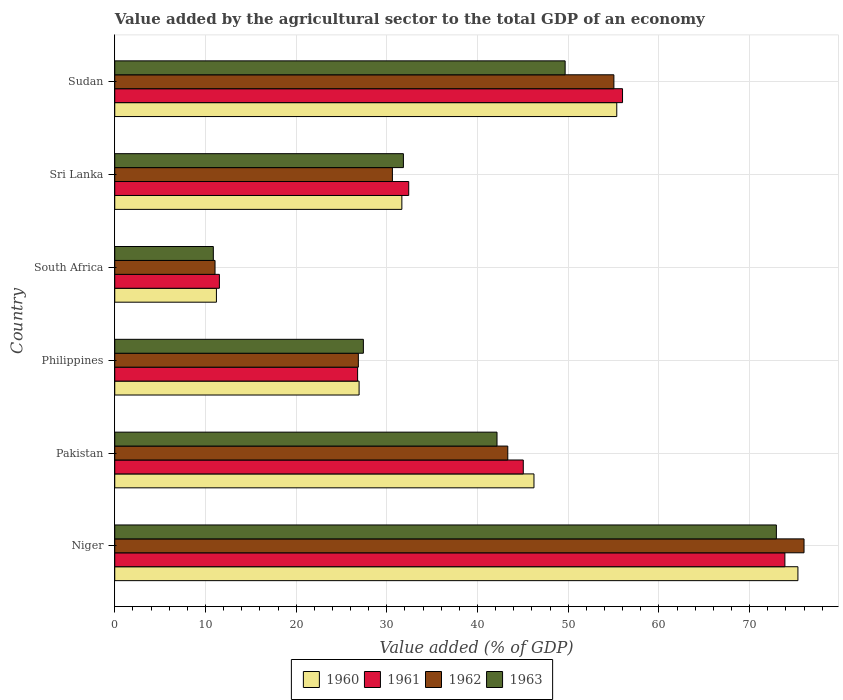How many groups of bars are there?
Your answer should be very brief. 6. Are the number of bars per tick equal to the number of legend labels?
Your response must be concise. Yes. How many bars are there on the 3rd tick from the top?
Provide a succinct answer. 4. What is the value added by the agricultural sector to the total GDP in 1962 in Philippines?
Provide a short and direct response. 26.86. Across all countries, what is the maximum value added by the agricultural sector to the total GDP in 1960?
Ensure brevity in your answer.  75.32. Across all countries, what is the minimum value added by the agricultural sector to the total GDP in 1963?
Keep it short and to the point. 10.87. In which country was the value added by the agricultural sector to the total GDP in 1963 maximum?
Give a very brief answer. Niger. In which country was the value added by the agricultural sector to the total GDP in 1960 minimum?
Provide a succinct answer. South Africa. What is the total value added by the agricultural sector to the total GDP in 1961 in the graph?
Your answer should be very brief. 245.64. What is the difference between the value added by the agricultural sector to the total GDP in 1961 in Philippines and that in Sudan?
Your answer should be very brief. -29.21. What is the difference between the value added by the agricultural sector to the total GDP in 1960 in Sudan and the value added by the agricultural sector to the total GDP in 1962 in Sri Lanka?
Offer a very short reply. 24.74. What is the average value added by the agricultural sector to the total GDP in 1961 per country?
Provide a succinct answer. 40.94. What is the difference between the value added by the agricultural sector to the total GDP in 1961 and value added by the agricultural sector to the total GDP in 1963 in Niger?
Keep it short and to the point. 0.94. In how many countries, is the value added by the agricultural sector to the total GDP in 1962 greater than 26 %?
Give a very brief answer. 5. What is the ratio of the value added by the agricultural sector to the total GDP in 1961 in Philippines to that in Sri Lanka?
Your response must be concise. 0.83. Is the value added by the agricultural sector to the total GDP in 1961 in Pakistan less than that in Sri Lanka?
Offer a very short reply. No. What is the difference between the highest and the second highest value added by the agricultural sector to the total GDP in 1961?
Make the answer very short. 17.9. What is the difference between the highest and the lowest value added by the agricultural sector to the total GDP in 1960?
Keep it short and to the point. 64.11. Is the sum of the value added by the agricultural sector to the total GDP in 1960 in South Africa and Sri Lanka greater than the maximum value added by the agricultural sector to the total GDP in 1963 across all countries?
Give a very brief answer. No. Is it the case that in every country, the sum of the value added by the agricultural sector to the total GDP in 1962 and value added by the agricultural sector to the total GDP in 1961 is greater than the sum of value added by the agricultural sector to the total GDP in 1960 and value added by the agricultural sector to the total GDP in 1963?
Give a very brief answer. No. What does the 3rd bar from the bottom in Niger represents?
Provide a short and direct response. 1962. How many bars are there?
Provide a short and direct response. 24. Are all the bars in the graph horizontal?
Offer a very short reply. Yes. How many countries are there in the graph?
Give a very brief answer. 6. Are the values on the major ticks of X-axis written in scientific E-notation?
Provide a short and direct response. No. Does the graph contain grids?
Your answer should be compact. Yes. How many legend labels are there?
Provide a succinct answer. 4. What is the title of the graph?
Your response must be concise. Value added by the agricultural sector to the total GDP of an economy. Does "1978" appear as one of the legend labels in the graph?
Offer a terse response. No. What is the label or title of the X-axis?
Make the answer very short. Value added (% of GDP). What is the Value added (% of GDP) in 1960 in Niger?
Provide a succinct answer. 75.32. What is the Value added (% of GDP) in 1961 in Niger?
Your answer should be very brief. 73.89. What is the Value added (% of GDP) in 1962 in Niger?
Give a very brief answer. 76. What is the Value added (% of GDP) of 1963 in Niger?
Provide a short and direct response. 72.95. What is the Value added (% of GDP) of 1960 in Pakistan?
Ensure brevity in your answer.  46.22. What is the Value added (% of GDP) of 1961 in Pakistan?
Give a very brief answer. 45.04. What is the Value added (% of GDP) of 1962 in Pakistan?
Offer a terse response. 43.33. What is the Value added (% of GDP) of 1963 in Pakistan?
Offer a terse response. 42.15. What is the Value added (% of GDP) of 1960 in Philippines?
Keep it short and to the point. 26.94. What is the Value added (% of GDP) of 1961 in Philippines?
Your answer should be very brief. 26.78. What is the Value added (% of GDP) of 1962 in Philippines?
Your answer should be compact. 26.86. What is the Value added (% of GDP) of 1963 in Philippines?
Provide a short and direct response. 27.41. What is the Value added (% of GDP) of 1960 in South Africa?
Provide a short and direct response. 11.21. What is the Value added (% of GDP) in 1961 in South Africa?
Provide a short and direct response. 11.54. What is the Value added (% of GDP) of 1962 in South Africa?
Your response must be concise. 11.06. What is the Value added (% of GDP) in 1963 in South Africa?
Your answer should be compact. 10.87. What is the Value added (% of GDP) in 1960 in Sri Lanka?
Give a very brief answer. 31.66. What is the Value added (% of GDP) in 1961 in Sri Lanka?
Offer a very short reply. 32.41. What is the Value added (% of GDP) of 1962 in Sri Lanka?
Give a very brief answer. 30.61. What is the Value added (% of GDP) of 1963 in Sri Lanka?
Provide a succinct answer. 31.83. What is the Value added (% of GDP) of 1960 in Sudan?
Your answer should be very brief. 55.35. What is the Value added (% of GDP) of 1961 in Sudan?
Make the answer very short. 55.99. What is the Value added (% of GDP) in 1962 in Sudan?
Your response must be concise. 55.03. What is the Value added (% of GDP) of 1963 in Sudan?
Keep it short and to the point. 49.66. Across all countries, what is the maximum Value added (% of GDP) of 1960?
Your response must be concise. 75.32. Across all countries, what is the maximum Value added (% of GDP) of 1961?
Your response must be concise. 73.89. Across all countries, what is the maximum Value added (% of GDP) of 1962?
Give a very brief answer. 76. Across all countries, what is the maximum Value added (% of GDP) of 1963?
Make the answer very short. 72.95. Across all countries, what is the minimum Value added (% of GDP) of 1960?
Your answer should be compact. 11.21. Across all countries, what is the minimum Value added (% of GDP) in 1961?
Offer a very short reply. 11.54. Across all countries, what is the minimum Value added (% of GDP) in 1962?
Your response must be concise. 11.06. Across all countries, what is the minimum Value added (% of GDP) in 1963?
Your answer should be compact. 10.87. What is the total Value added (% of GDP) in 1960 in the graph?
Provide a short and direct response. 246.7. What is the total Value added (% of GDP) in 1961 in the graph?
Offer a very short reply. 245.64. What is the total Value added (% of GDP) in 1962 in the graph?
Your response must be concise. 242.89. What is the total Value added (% of GDP) of 1963 in the graph?
Offer a very short reply. 234.86. What is the difference between the Value added (% of GDP) of 1960 in Niger and that in Pakistan?
Provide a succinct answer. 29.1. What is the difference between the Value added (% of GDP) of 1961 in Niger and that in Pakistan?
Make the answer very short. 28.84. What is the difference between the Value added (% of GDP) in 1962 in Niger and that in Pakistan?
Your answer should be compact. 32.66. What is the difference between the Value added (% of GDP) in 1963 in Niger and that in Pakistan?
Provide a short and direct response. 30.8. What is the difference between the Value added (% of GDP) of 1960 in Niger and that in Philippines?
Make the answer very short. 48.38. What is the difference between the Value added (% of GDP) in 1961 in Niger and that in Philippines?
Offer a very short reply. 47.11. What is the difference between the Value added (% of GDP) of 1962 in Niger and that in Philippines?
Your answer should be compact. 49.14. What is the difference between the Value added (% of GDP) of 1963 in Niger and that in Philippines?
Keep it short and to the point. 45.54. What is the difference between the Value added (% of GDP) of 1960 in Niger and that in South Africa?
Offer a very short reply. 64.11. What is the difference between the Value added (% of GDP) in 1961 in Niger and that in South Africa?
Offer a very short reply. 62.35. What is the difference between the Value added (% of GDP) in 1962 in Niger and that in South Africa?
Your answer should be compact. 64.94. What is the difference between the Value added (% of GDP) of 1963 in Niger and that in South Africa?
Make the answer very short. 62.08. What is the difference between the Value added (% of GDP) of 1960 in Niger and that in Sri Lanka?
Your response must be concise. 43.67. What is the difference between the Value added (% of GDP) in 1961 in Niger and that in Sri Lanka?
Offer a very short reply. 41.48. What is the difference between the Value added (% of GDP) of 1962 in Niger and that in Sri Lanka?
Ensure brevity in your answer.  45.38. What is the difference between the Value added (% of GDP) in 1963 in Niger and that in Sri Lanka?
Your answer should be very brief. 41.12. What is the difference between the Value added (% of GDP) in 1960 in Niger and that in Sudan?
Offer a terse response. 19.97. What is the difference between the Value added (% of GDP) in 1961 in Niger and that in Sudan?
Your response must be concise. 17.9. What is the difference between the Value added (% of GDP) in 1962 in Niger and that in Sudan?
Provide a short and direct response. 20.96. What is the difference between the Value added (% of GDP) in 1963 in Niger and that in Sudan?
Offer a very short reply. 23.29. What is the difference between the Value added (% of GDP) of 1960 in Pakistan and that in Philippines?
Your answer should be compact. 19.28. What is the difference between the Value added (% of GDP) of 1961 in Pakistan and that in Philippines?
Your answer should be compact. 18.27. What is the difference between the Value added (% of GDP) of 1962 in Pakistan and that in Philippines?
Your response must be concise. 16.48. What is the difference between the Value added (% of GDP) in 1963 in Pakistan and that in Philippines?
Offer a terse response. 14.73. What is the difference between the Value added (% of GDP) in 1960 in Pakistan and that in South Africa?
Ensure brevity in your answer.  35.01. What is the difference between the Value added (% of GDP) in 1961 in Pakistan and that in South Africa?
Offer a terse response. 33.51. What is the difference between the Value added (% of GDP) of 1962 in Pakistan and that in South Africa?
Ensure brevity in your answer.  32.28. What is the difference between the Value added (% of GDP) of 1963 in Pakistan and that in South Africa?
Offer a terse response. 31.28. What is the difference between the Value added (% of GDP) in 1960 in Pakistan and that in Sri Lanka?
Your response must be concise. 14.56. What is the difference between the Value added (% of GDP) in 1961 in Pakistan and that in Sri Lanka?
Provide a short and direct response. 12.63. What is the difference between the Value added (% of GDP) in 1962 in Pakistan and that in Sri Lanka?
Give a very brief answer. 12.72. What is the difference between the Value added (% of GDP) of 1963 in Pakistan and that in Sri Lanka?
Provide a short and direct response. 10.32. What is the difference between the Value added (% of GDP) of 1960 in Pakistan and that in Sudan?
Your answer should be compact. -9.13. What is the difference between the Value added (% of GDP) in 1961 in Pakistan and that in Sudan?
Provide a short and direct response. -10.94. What is the difference between the Value added (% of GDP) of 1962 in Pakistan and that in Sudan?
Provide a succinct answer. -11.7. What is the difference between the Value added (% of GDP) in 1963 in Pakistan and that in Sudan?
Offer a very short reply. -7.51. What is the difference between the Value added (% of GDP) in 1960 in Philippines and that in South Africa?
Ensure brevity in your answer.  15.73. What is the difference between the Value added (% of GDP) in 1961 in Philippines and that in South Africa?
Keep it short and to the point. 15.24. What is the difference between the Value added (% of GDP) in 1962 in Philippines and that in South Africa?
Offer a very short reply. 15.8. What is the difference between the Value added (% of GDP) of 1963 in Philippines and that in South Africa?
Provide a succinct answer. 16.54. What is the difference between the Value added (% of GDP) of 1960 in Philippines and that in Sri Lanka?
Provide a succinct answer. -4.72. What is the difference between the Value added (% of GDP) of 1961 in Philippines and that in Sri Lanka?
Make the answer very short. -5.63. What is the difference between the Value added (% of GDP) in 1962 in Philippines and that in Sri Lanka?
Make the answer very short. -3.76. What is the difference between the Value added (% of GDP) of 1963 in Philippines and that in Sri Lanka?
Provide a short and direct response. -4.41. What is the difference between the Value added (% of GDP) of 1960 in Philippines and that in Sudan?
Your answer should be compact. -28.41. What is the difference between the Value added (% of GDP) in 1961 in Philippines and that in Sudan?
Keep it short and to the point. -29.21. What is the difference between the Value added (% of GDP) in 1962 in Philippines and that in Sudan?
Offer a terse response. -28.18. What is the difference between the Value added (% of GDP) in 1963 in Philippines and that in Sudan?
Your response must be concise. -22.25. What is the difference between the Value added (% of GDP) of 1960 in South Africa and that in Sri Lanka?
Give a very brief answer. -20.45. What is the difference between the Value added (% of GDP) of 1961 in South Africa and that in Sri Lanka?
Offer a terse response. -20.87. What is the difference between the Value added (% of GDP) of 1962 in South Africa and that in Sri Lanka?
Your answer should be very brief. -19.56. What is the difference between the Value added (% of GDP) of 1963 in South Africa and that in Sri Lanka?
Offer a very short reply. -20.96. What is the difference between the Value added (% of GDP) in 1960 in South Africa and that in Sudan?
Ensure brevity in your answer.  -44.14. What is the difference between the Value added (% of GDP) in 1961 in South Africa and that in Sudan?
Provide a succinct answer. -44.45. What is the difference between the Value added (% of GDP) of 1962 in South Africa and that in Sudan?
Provide a short and direct response. -43.98. What is the difference between the Value added (% of GDP) of 1963 in South Africa and that in Sudan?
Provide a succinct answer. -38.79. What is the difference between the Value added (% of GDP) of 1960 in Sri Lanka and that in Sudan?
Give a very brief answer. -23.7. What is the difference between the Value added (% of GDP) in 1961 in Sri Lanka and that in Sudan?
Offer a very short reply. -23.58. What is the difference between the Value added (% of GDP) in 1962 in Sri Lanka and that in Sudan?
Offer a terse response. -24.42. What is the difference between the Value added (% of GDP) of 1963 in Sri Lanka and that in Sudan?
Your answer should be compact. -17.83. What is the difference between the Value added (% of GDP) of 1960 in Niger and the Value added (% of GDP) of 1961 in Pakistan?
Offer a very short reply. 30.28. What is the difference between the Value added (% of GDP) of 1960 in Niger and the Value added (% of GDP) of 1962 in Pakistan?
Ensure brevity in your answer.  31.99. What is the difference between the Value added (% of GDP) of 1960 in Niger and the Value added (% of GDP) of 1963 in Pakistan?
Provide a short and direct response. 33.18. What is the difference between the Value added (% of GDP) of 1961 in Niger and the Value added (% of GDP) of 1962 in Pakistan?
Give a very brief answer. 30.55. What is the difference between the Value added (% of GDP) of 1961 in Niger and the Value added (% of GDP) of 1963 in Pakistan?
Offer a very short reply. 31.74. What is the difference between the Value added (% of GDP) of 1962 in Niger and the Value added (% of GDP) of 1963 in Pakistan?
Offer a terse response. 33.85. What is the difference between the Value added (% of GDP) in 1960 in Niger and the Value added (% of GDP) in 1961 in Philippines?
Give a very brief answer. 48.55. What is the difference between the Value added (% of GDP) of 1960 in Niger and the Value added (% of GDP) of 1962 in Philippines?
Offer a terse response. 48.47. What is the difference between the Value added (% of GDP) of 1960 in Niger and the Value added (% of GDP) of 1963 in Philippines?
Keep it short and to the point. 47.91. What is the difference between the Value added (% of GDP) in 1961 in Niger and the Value added (% of GDP) in 1962 in Philippines?
Keep it short and to the point. 47.03. What is the difference between the Value added (% of GDP) in 1961 in Niger and the Value added (% of GDP) in 1963 in Philippines?
Your answer should be very brief. 46.48. What is the difference between the Value added (% of GDP) in 1962 in Niger and the Value added (% of GDP) in 1963 in Philippines?
Ensure brevity in your answer.  48.59. What is the difference between the Value added (% of GDP) in 1960 in Niger and the Value added (% of GDP) in 1961 in South Africa?
Ensure brevity in your answer.  63.79. What is the difference between the Value added (% of GDP) of 1960 in Niger and the Value added (% of GDP) of 1962 in South Africa?
Offer a very short reply. 64.27. What is the difference between the Value added (% of GDP) of 1960 in Niger and the Value added (% of GDP) of 1963 in South Africa?
Keep it short and to the point. 64.46. What is the difference between the Value added (% of GDP) in 1961 in Niger and the Value added (% of GDP) in 1962 in South Africa?
Keep it short and to the point. 62.83. What is the difference between the Value added (% of GDP) of 1961 in Niger and the Value added (% of GDP) of 1963 in South Africa?
Make the answer very short. 63.02. What is the difference between the Value added (% of GDP) in 1962 in Niger and the Value added (% of GDP) in 1963 in South Africa?
Provide a succinct answer. 65.13. What is the difference between the Value added (% of GDP) of 1960 in Niger and the Value added (% of GDP) of 1961 in Sri Lanka?
Keep it short and to the point. 42.91. What is the difference between the Value added (% of GDP) in 1960 in Niger and the Value added (% of GDP) in 1962 in Sri Lanka?
Provide a succinct answer. 44.71. What is the difference between the Value added (% of GDP) in 1960 in Niger and the Value added (% of GDP) in 1963 in Sri Lanka?
Offer a very short reply. 43.5. What is the difference between the Value added (% of GDP) of 1961 in Niger and the Value added (% of GDP) of 1962 in Sri Lanka?
Provide a succinct answer. 43.27. What is the difference between the Value added (% of GDP) in 1961 in Niger and the Value added (% of GDP) in 1963 in Sri Lanka?
Provide a short and direct response. 42.06. What is the difference between the Value added (% of GDP) of 1962 in Niger and the Value added (% of GDP) of 1963 in Sri Lanka?
Your answer should be compact. 44.17. What is the difference between the Value added (% of GDP) of 1960 in Niger and the Value added (% of GDP) of 1961 in Sudan?
Offer a terse response. 19.34. What is the difference between the Value added (% of GDP) in 1960 in Niger and the Value added (% of GDP) in 1962 in Sudan?
Give a very brief answer. 20.29. What is the difference between the Value added (% of GDP) of 1960 in Niger and the Value added (% of GDP) of 1963 in Sudan?
Offer a very short reply. 25.67. What is the difference between the Value added (% of GDP) in 1961 in Niger and the Value added (% of GDP) in 1962 in Sudan?
Offer a very short reply. 18.85. What is the difference between the Value added (% of GDP) in 1961 in Niger and the Value added (% of GDP) in 1963 in Sudan?
Make the answer very short. 24.23. What is the difference between the Value added (% of GDP) in 1962 in Niger and the Value added (% of GDP) in 1963 in Sudan?
Provide a succinct answer. 26.34. What is the difference between the Value added (% of GDP) in 1960 in Pakistan and the Value added (% of GDP) in 1961 in Philippines?
Provide a succinct answer. 19.44. What is the difference between the Value added (% of GDP) in 1960 in Pakistan and the Value added (% of GDP) in 1962 in Philippines?
Your response must be concise. 19.36. What is the difference between the Value added (% of GDP) in 1960 in Pakistan and the Value added (% of GDP) in 1963 in Philippines?
Provide a succinct answer. 18.81. What is the difference between the Value added (% of GDP) in 1961 in Pakistan and the Value added (% of GDP) in 1962 in Philippines?
Offer a terse response. 18.19. What is the difference between the Value added (% of GDP) in 1961 in Pakistan and the Value added (% of GDP) in 1963 in Philippines?
Make the answer very short. 17.63. What is the difference between the Value added (% of GDP) of 1962 in Pakistan and the Value added (% of GDP) of 1963 in Philippines?
Offer a terse response. 15.92. What is the difference between the Value added (% of GDP) in 1960 in Pakistan and the Value added (% of GDP) in 1961 in South Africa?
Offer a very short reply. 34.68. What is the difference between the Value added (% of GDP) of 1960 in Pakistan and the Value added (% of GDP) of 1962 in South Africa?
Provide a short and direct response. 35.16. What is the difference between the Value added (% of GDP) of 1960 in Pakistan and the Value added (% of GDP) of 1963 in South Africa?
Provide a short and direct response. 35.35. What is the difference between the Value added (% of GDP) in 1961 in Pakistan and the Value added (% of GDP) in 1962 in South Africa?
Your answer should be very brief. 33.99. What is the difference between the Value added (% of GDP) of 1961 in Pakistan and the Value added (% of GDP) of 1963 in South Africa?
Your response must be concise. 34.17. What is the difference between the Value added (% of GDP) of 1962 in Pakistan and the Value added (% of GDP) of 1963 in South Africa?
Provide a succinct answer. 32.46. What is the difference between the Value added (% of GDP) in 1960 in Pakistan and the Value added (% of GDP) in 1961 in Sri Lanka?
Your answer should be very brief. 13.81. What is the difference between the Value added (% of GDP) in 1960 in Pakistan and the Value added (% of GDP) in 1962 in Sri Lanka?
Provide a succinct answer. 15.61. What is the difference between the Value added (% of GDP) in 1960 in Pakistan and the Value added (% of GDP) in 1963 in Sri Lanka?
Make the answer very short. 14.39. What is the difference between the Value added (% of GDP) in 1961 in Pakistan and the Value added (% of GDP) in 1962 in Sri Lanka?
Keep it short and to the point. 14.43. What is the difference between the Value added (% of GDP) of 1961 in Pakistan and the Value added (% of GDP) of 1963 in Sri Lanka?
Make the answer very short. 13.22. What is the difference between the Value added (% of GDP) in 1962 in Pakistan and the Value added (% of GDP) in 1963 in Sri Lanka?
Provide a succinct answer. 11.51. What is the difference between the Value added (% of GDP) of 1960 in Pakistan and the Value added (% of GDP) of 1961 in Sudan?
Make the answer very short. -9.77. What is the difference between the Value added (% of GDP) of 1960 in Pakistan and the Value added (% of GDP) of 1962 in Sudan?
Make the answer very short. -8.81. What is the difference between the Value added (% of GDP) in 1960 in Pakistan and the Value added (% of GDP) in 1963 in Sudan?
Your answer should be compact. -3.44. What is the difference between the Value added (% of GDP) in 1961 in Pakistan and the Value added (% of GDP) in 1962 in Sudan?
Make the answer very short. -9.99. What is the difference between the Value added (% of GDP) in 1961 in Pakistan and the Value added (% of GDP) in 1963 in Sudan?
Give a very brief answer. -4.62. What is the difference between the Value added (% of GDP) of 1962 in Pakistan and the Value added (% of GDP) of 1963 in Sudan?
Make the answer very short. -6.33. What is the difference between the Value added (% of GDP) in 1960 in Philippines and the Value added (% of GDP) in 1961 in South Africa?
Your response must be concise. 15.4. What is the difference between the Value added (% of GDP) of 1960 in Philippines and the Value added (% of GDP) of 1962 in South Africa?
Your answer should be very brief. 15.88. What is the difference between the Value added (% of GDP) in 1960 in Philippines and the Value added (% of GDP) in 1963 in South Africa?
Provide a succinct answer. 16.07. What is the difference between the Value added (% of GDP) of 1961 in Philippines and the Value added (% of GDP) of 1962 in South Africa?
Ensure brevity in your answer.  15.72. What is the difference between the Value added (% of GDP) of 1961 in Philippines and the Value added (% of GDP) of 1963 in South Africa?
Offer a terse response. 15.91. What is the difference between the Value added (% of GDP) of 1962 in Philippines and the Value added (% of GDP) of 1963 in South Africa?
Offer a very short reply. 15.99. What is the difference between the Value added (% of GDP) in 1960 in Philippines and the Value added (% of GDP) in 1961 in Sri Lanka?
Your answer should be very brief. -5.47. What is the difference between the Value added (% of GDP) in 1960 in Philippines and the Value added (% of GDP) in 1962 in Sri Lanka?
Keep it short and to the point. -3.67. What is the difference between the Value added (% of GDP) in 1960 in Philippines and the Value added (% of GDP) in 1963 in Sri Lanka?
Ensure brevity in your answer.  -4.89. What is the difference between the Value added (% of GDP) of 1961 in Philippines and the Value added (% of GDP) of 1962 in Sri Lanka?
Ensure brevity in your answer.  -3.84. What is the difference between the Value added (% of GDP) of 1961 in Philippines and the Value added (% of GDP) of 1963 in Sri Lanka?
Provide a short and direct response. -5.05. What is the difference between the Value added (% of GDP) of 1962 in Philippines and the Value added (% of GDP) of 1963 in Sri Lanka?
Your answer should be very brief. -4.97. What is the difference between the Value added (% of GDP) in 1960 in Philippines and the Value added (% of GDP) in 1961 in Sudan?
Ensure brevity in your answer.  -29.05. What is the difference between the Value added (% of GDP) in 1960 in Philippines and the Value added (% of GDP) in 1962 in Sudan?
Your answer should be very brief. -28.09. What is the difference between the Value added (% of GDP) in 1960 in Philippines and the Value added (% of GDP) in 1963 in Sudan?
Your answer should be compact. -22.72. What is the difference between the Value added (% of GDP) of 1961 in Philippines and the Value added (% of GDP) of 1962 in Sudan?
Your response must be concise. -28.26. What is the difference between the Value added (% of GDP) of 1961 in Philippines and the Value added (% of GDP) of 1963 in Sudan?
Your answer should be very brief. -22.88. What is the difference between the Value added (% of GDP) of 1962 in Philippines and the Value added (% of GDP) of 1963 in Sudan?
Keep it short and to the point. -22.8. What is the difference between the Value added (% of GDP) of 1960 in South Africa and the Value added (% of GDP) of 1961 in Sri Lanka?
Ensure brevity in your answer.  -21.2. What is the difference between the Value added (% of GDP) in 1960 in South Africa and the Value added (% of GDP) in 1962 in Sri Lanka?
Keep it short and to the point. -19.4. What is the difference between the Value added (% of GDP) of 1960 in South Africa and the Value added (% of GDP) of 1963 in Sri Lanka?
Keep it short and to the point. -20.62. What is the difference between the Value added (% of GDP) in 1961 in South Africa and the Value added (% of GDP) in 1962 in Sri Lanka?
Your response must be concise. -19.08. What is the difference between the Value added (% of GDP) of 1961 in South Africa and the Value added (% of GDP) of 1963 in Sri Lanka?
Your answer should be very brief. -20.29. What is the difference between the Value added (% of GDP) in 1962 in South Africa and the Value added (% of GDP) in 1963 in Sri Lanka?
Provide a short and direct response. -20.77. What is the difference between the Value added (% of GDP) of 1960 in South Africa and the Value added (% of GDP) of 1961 in Sudan?
Offer a very short reply. -44.78. What is the difference between the Value added (% of GDP) of 1960 in South Africa and the Value added (% of GDP) of 1962 in Sudan?
Your answer should be very brief. -43.82. What is the difference between the Value added (% of GDP) of 1960 in South Africa and the Value added (% of GDP) of 1963 in Sudan?
Your answer should be compact. -38.45. What is the difference between the Value added (% of GDP) of 1961 in South Africa and the Value added (% of GDP) of 1962 in Sudan?
Offer a terse response. -43.5. What is the difference between the Value added (% of GDP) of 1961 in South Africa and the Value added (% of GDP) of 1963 in Sudan?
Offer a very short reply. -38.12. What is the difference between the Value added (% of GDP) in 1962 in South Africa and the Value added (% of GDP) in 1963 in Sudan?
Give a very brief answer. -38.6. What is the difference between the Value added (% of GDP) in 1960 in Sri Lanka and the Value added (% of GDP) in 1961 in Sudan?
Offer a terse response. -24.33. What is the difference between the Value added (% of GDP) of 1960 in Sri Lanka and the Value added (% of GDP) of 1962 in Sudan?
Offer a very short reply. -23.38. What is the difference between the Value added (% of GDP) of 1960 in Sri Lanka and the Value added (% of GDP) of 1963 in Sudan?
Give a very brief answer. -18. What is the difference between the Value added (% of GDP) of 1961 in Sri Lanka and the Value added (% of GDP) of 1962 in Sudan?
Make the answer very short. -22.62. What is the difference between the Value added (% of GDP) of 1961 in Sri Lanka and the Value added (% of GDP) of 1963 in Sudan?
Your response must be concise. -17.25. What is the difference between the Value added (% of GDP) in 1962 in Sri Lanka and the Value added (% of GDP) in 1963 in Sudan?
Provide a succinct answer. -19.04. What is the average Value added (% of GDP) of 1960 per country?
Your answer should be compact. 41.12. What is the average Value added (% of GDP) of 1961 per country?
Provide a short and direct response. 40.94. What is the average Value added (% of GDP) of 1962 per country?
Keep it short and to the point. 40.48. What is the average Value added (% of GDP) of 1963 per country?
Make the answer very short. 39.14. What is the difference between the Value added (% of GDP) in 1960 and Value added (% of GDP) in 1961 in Niger?
Make the answer very short. 1.44. What is the difference between the Value added (% of GDP) in 1960 and Value added (% of GDP) in 1962 in Niger?
Your response must be concise. -0.67. What is the difference between the Value added (% of GDP) of 1960 and Value added (% of GDP) of 1963 in Niger?
Make the answer very short. 2.38. What is the difference between the Value added (% of GDP) of 1961 and Value added (% of GDP) of 1962 in Niger?
Your answer should be compact. -2.11. What is the difference between the Value added (% of GDP) of 1961 and Value added (% of GDP) of 1963 in Niger?
Ensure brevity in your answer.  0.94. What is the difference between the Value added (% of GDP) in 1962 and Value added (% of GDP) in 1963 in Niger?
Your response must be concise. 3.05. What is the difference between the Value added (% of GDP) in 1960 and Value added (% of GDP) in 1961 in Pakistan?
Make the answer very short. 1.18. What is the difference between the Value added (% of GDP) in 1960 and Value added (% of GDP) in 1962 in Pakistan?
Ensure brevity in your answer.  2.89. What is the difference between the Value added (% of GDP) in 1960 and Value added (% of GDP) in 1963 in Pakistan?
Ensure brevity in your answer.  4.07. What is the difference between the Value added (% of GDP) of 1961 and Value added (% of GDP) of 1962 in Pakistan?
Keep it short and to the point. 1.71. What is the difference between the Value added (% of GDP) of 1961 and Value added (% of GDP) of 1963 in Pakistan?
Your response must be concise. 2.9. What is the difference between the Value added (% of GDP) in 1962 and Value added (% of GDP) in 1963 in Pakistan?
Give a very brief answer. 1.19. What is the difference between the Value added (% of GDP) of 1960 and Value added (% of GDP) of 1961 in Philippines?
Your answer should be compact. 0.16. What is the difference between the Value added (% of GDP) in 1960 and Value added (% of GDP) in 1962 in Philippines?
Make the answer very short. 0.08. What is the difference between the Value added (% of GDP) in 1960 and Value added (% of GDP) in 1963 in Philippines?
Make the answer very short. -0.47. What is the difference between the Value added (% of GDP) in 1961 and Value added (% of GDP) in 1962 in Philippines?
Offer a very short reply. -0.08. What is the difference between the Value added (% of GDP) in 1961 and Value added (% of GDP) in 1963 in Philippines?
Provide a succinct answer. -0.64. What is the difference between the Value added (% of GDP) of 1962 and Value added (% of GDP) of 1963 in Philippines?
Provide a short and direct response. -0.55. What is the difference between the Value added (% of GDP) in 1960 and Value added (% of GDP) in 1961 in South Africa?
Keep it short and to the point. -0.33. What is the difference between the Value added (% of GDP) in 1960 and Value added (% of GDP) in 1962 in South Africa?
Offer a very short reply. 0.15. What is the difference between the Value added (% of GDP) in 1960 and Value added (% of GDP) in 1963 in South Africa?
Your answer should be compact. 0.34. What is the difference between the Value added (% of GDP) in 1961 and Value added (% of GDP) in 1962 in South Africa?
Ensure brevity in your answer.  0.48. What is the difference between the Value added (% of GDP) of 1961 and Value added (% of GDP) of 1963 in South Africa?
Give a very brief answer. 0.67. What is the difference between the Value added (% of GDP) of 1962 and Value added (% of GDP) of 1963 in South Africa?
Provide a succinct answer. 0.19. What is the difference between the Value added (% of GDP) of 1960 and Value added (% of GDP) of 1961 in Sri Lanka?
Your response must be concise. -0.76. What is the difference between the Value added (% of GDP) of 1960 and Value added (% of GDP) of 1962 in Sri Lanka?
Provide a short and direct response. 1.04. What is the difference between the Value added (% of GDP) of 1960 and Value added (% of GDP) of 1963 in Sri Lanka?
Ensure brevity in your answer.  -0.17. What is the difference between the Value added (% of GDP) of 1961 and Value added (% of GDP) of 1962 in Sri Lanka?
Keep it short and to the point. 1.8. What is the difference between the Value added (% of GDP) of 1961 and Value added (% of GDP) of 1963 in Sri Lanka?
Offer a very short reply. 0.59. What is the difference between the Value added (% of GDP) of 1962 and Value added (% of GDP) of 1963 in Sri Lanka?
Offer a terse response. -1.21. What is the difference between the Value added (% of GDP) of 1960 and Value added (% of GDP) of 1961 in Sudan?
Keep it short and to the point. -0.64. What is the difference between the Value added (% of GDP) of 1960 and Value added (% of GDP) of 1962 in Sudan?
Offer a very short reply. 0.32. What is the difference between the Value added (% of GDP) of 1960 and Value added (% of GDP) of 1963 in Sudan?
Give a very brief answer. 5.69. What is the difference between the Value added (% of GDP) of 1961 and Value added (% of GDP) of 1962 in Sudan?
Make the answer very short. 0.95. What is the difference between the Value added (% of GDP) in 1961 and Value added (% of GDP) in 1963 in Sudan?
Your response must be concise. 6.33. What is the difference between the Value added (% of GDP) in 1962 and Value added (% of GDP) in 1963 in Sudan?
Provide a short and direct response. 5.37. What is the ratio of the Value added (% of GDP) in 1960 in Niger to that in Pakistan?
Offer a terse response. 1.63. What is the ratio of the Value added (% of GDP) in 1961 in Niger to that in Pakistan?
Provide a succinct answer. 1.64. What is the ratio of the Value added (% of GDP) in 1962 in Niger to that in Pakistan?
Give a very brief answer. 1.75. What is the ratio of the Value added (% of GDP) in 1963 in Niger to that in Pakistan?
Provide a succinct answer. 1.73. What is the ratio of the Value added (% of GDP) of 1960 in Niger to that in Philippines?
Make the answer very short. 2.8. What is the ratio of the Value added (% of GDP) in 1961 in Niger to that in Philippines?
Offer a very short reply. 2.76. What is the ratio of the Value added (% of GDP) in 1962 in Niger to that in Philippines?
Your response must be concise. 2.83. What is the ratio of the Value added (% of GDP) in 1963 in Niger to that in Philippines?
Ensure brevity in your answer.  2.66. What is the ratio of the Value added (% of GDP) of 1960 in Niger to that in South Africa?
Provide a short and direct response. 6.72. What is the ratio of the Value added (% of GDP) of 1961 in Niger to that in South Africa?
Keep it short and to the point. 6.4. What is the ratio of the Value added (% of GDP) in 1962 in Niger to that in South Africa?
Your response must be concise. 6.87. What is the ratio of the Value added (% of GDP) of 1963 in Niger to that in South Africa?
Give a very brief answer. 6.71. What is the ratio of the Value added (% of GDP) in 1960 in Niger to that in Sri Lanka?
Give a very brief answer. 2.38. What is the ratio of the Value added (% of GDP) of 1961 in Niger to that in Sri Lanka?
Your answer should be very brief. 2.28. What is the ratio of the Value added (% of GDP) in 1962 in Niger to that in Sri Lanka?
Your answer should be very brief. 2.48. What is the ratio of the Value added (% of GDP) in 1963 in Niger to that in Sri Lanka?
Provide a succinct answer. 2.29. What is the ratio of the Value added (% of GDP) of 1960 in Niger to that in Sudan?
Your response must be concise. 1.36. What is the ratio of the Value added (% of GDP) in 1961 in Niger to that in Sudan?
Your response must be concise. 1.32. What is the ratio of the Value added (% of GDP) of 1962 in Niger to that in Sudan?
Ensure brevity in your answer.  1.38. What is the ratio of the Value added (% of GDP) of 1963 in Niger to that in Sudan?
Keep it short and to the point. 1.47. What is the ratio of the Value added (% of GDP) of 1960 in Pakistan to that in Philippines?
Offer a very short reply. 1.72. What is the ratio of the Value added (% of GDP) in 1961 in Pakistan to that in Philippines?
Give a very brief answer. 1.68. What is the ratio of the Value added (% of GDP) in 1962 in Pakistan to that in Philippines?
Make the answer very short. 1.61. What is the ratio of the Value added (% of GDP) of 1963 in Pakistan to that in Philippines?
Your response must be concise. 1.54. What is the ratio of the Value added (% of GDP) in 1960 in Pakistan to that in South Africa?
Make the answer very short. 4.12. What is the ratio of the Value added (% of GDP) in 1961 in Pakistan to that in South Africa?
Make the answer very short. 3.9. What is the ratio of the Value added (% of GDP) of 1962 in Pakistan to that in South Africa?
Provide a succinct answer. 3.92. What is the ratio of the Value added (% of GDP) in 1963 in Pakistan to that in South Africa?
Your response must be concise. 3.88. What is the ratio of the Value added (% of GDP) in 1960 in Pakistan to that in Sri Lanka?
Provide a succinct answer. 1.46. What is the ratio of the Value added (% of GDP) in 1961 in Pakistan to that in Sri Lanka?
Give a very brief answer. 1.39. What is the ratio of the Value added (% of GDP) in 1962 in Pakistan to that in Sri Lanka?
Ensure brevity in your answer.  1.42. What is the ratio of the Value added (% of GDP) in 1963 in Pakistan to that in Sri Lanka?
Offer a terse response. 1.32. What is the ratio of the Value added (% of GDP) of 1960 in Pakistan to that in Sudan?
Give a very brief answer. 0.83. What is the ratio of the Value added (% of GDP) in 1961 in Pakistan to that in Sudan?
Your response must be concise. 0.8. What is the ratio of the Value added (% of GDP) in 1962 in Pakistan to that in Sudan?
Keep it short and to the point. 0.79. What is the ratio of the Value added (% of GDP) in 1963 in Pakistan to that in Sudan?
Your answer should be compact. 0.85. What is the ratio of the Value added (% of GDP) in 1960 in Philippines to that in South Africa?
Make the answer very short. 2.4. What is the ratio of the Value added (% of GDP) of 1961 in Philippines to that in South Africa?
Keep it short and to the point. 2.32. What is the ratio of the Value added (% of GDP) in 1962 in Philippines to that in South Africa?
Give a very brief answer. 2.43. What is the ratio of the Value added (% of GDP) in 1963 in Philippines to that in South Africa?
Ensure brevity in your answer.  2.52. What is the ratio of the Value added (% of GDP) in 1960 in Philippines to that in Sri Lanka?
Provide a succinct answer. 0.85. What is the ratio of the Value added (% of GDP) of 1961 in Philippines to that in Sri Lanka?
Offer a very short reply. 0.83. What is the ratio of the Value added (% of GDP) of 1962 in Philippines to that in Sri Lanka?
Provide a succinct answer. 0.88. What is the ratio of the Value added (% of GDP) of 1963 in Philippines to that in Sri Lanka?
Ensure brevity in your answer.  0.86. What is the ratio of the Value added (% of GDP) of 1960 in Philippines to that in Sudan?
Your answer should be compact. 0.49. What is the ratio of the Value added (% of GDP) of 1961 in Philippines to that in Sudan?
Provide a succinct answer. 0.48. What is the ratio of the Value added (% of GDP) in 1962 in Philippines to that in Sudan?
Provide a short and direct response. 0.49. What is the ratio of the Value added (% of GDP) in 1963 in Philippines to that in Sudan?
Provide a short and direct response. 0.55. What is the ratio of the Value added (% of GDP) in 1960 in South Africa to that in Sri Lanka?
Your response must be concise. 0.35. What is the ratio of the Value added (% of GDP) in 1961 in South Africa to that in Sri Lanka?
Make the answer very short. 0.36. What is the ratio of the Value added (% of GDP) in 1962 in South Africa to that in Sri Lanka?
Give a very brief answer. 0.36. What is the ratio of the Value added (% of GDP) in 1963 in South Africa to that in Sri Lanka?
Give a very brief answer. 0.34. What is the ratio of the Value added (% of GDP) in 1960 in South Africa to that in Sudan?
Your response must be concise. 0.2. What is the ratio of the Value added (% of GDP) of 1961 in South Africa to that in Sudan?
Offer a very short reply. 0.21. What is the ratio of the Value added (% of GDP) in 1962 in South Africa to that in Sudan?
Your response must be concise. 0.2. What is the ratio of the Value added (% of GDP) in 1963 in South Africa to that in Sudan?
Offer a terse response. 0.22. What is the ratio of the Value added (% of GDP) in 1960 in Sri Lanka to that in Sudan?
Offer a very short reply. 0.57. What is the ratio of the Value added (% of GDP) in 1961 in Sri Lanka to that in Sudan?
Offer a terse response. 0.58. What is the ratio of the Value added (% of GDP) in 1962 in Sri Lanka to that in Sudan?
Your answer should be very brief. 0.56. What is the ratio of the Value added (% of GDP) in 1963 in Sri Lanka to that in Sudan?
Provide a succinct answer. 0.64. What is the difference between the highest and the second highest Value added (% of GDP) of 1960?
Keep it short and to the point. 19.97. What is the difference between the highest and the second highest Value added (% of GDP) in 1961?
Your answer should be compact. 17.9. What is the difference between the highest and the second highest Value added (% of GDP) of 1962?
Ensure brevity in your answer.  20.96. What is the difference between the highest and the second highest Value added (% of GDP) of 1963?
Your answer should be compact. 23.29. What is the difference between the highest and the lowest Value added (% of GDP) in 1960?
Your response must be concise. 64.11. What is the difference between the highest and the lowest Value added (% of GDP) of 1961?
Offer a very short reply. 62.35. What is the difference between the highest and the lowest Value added (% of GDP) of 1962?
Offer a very short reply. 64.94. What is the difference between the highest and the lowest Value added (% of GDP) of 1963?
Make the answer very short. 62.08. 